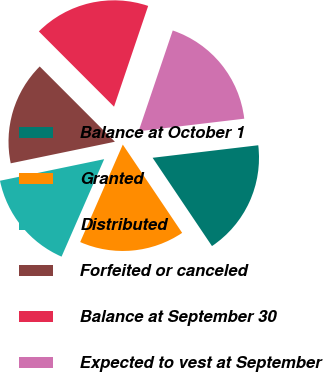Convert chart. <chart><loc_0><loc_0><loc_500><loc_500><pie_chart><fcel>Balance at October 1<fcel>Granted<fcel>Distributed<fcel>Forfeited or canceled<fcel>Balance at September 30<fcel>Expected to vest at September<nl><fcel>17.46%<fcel>15.98%<fcel>15.19%<fcel>15.76%<fcel>17.69%<fcel>17.92%<nl></chart> 